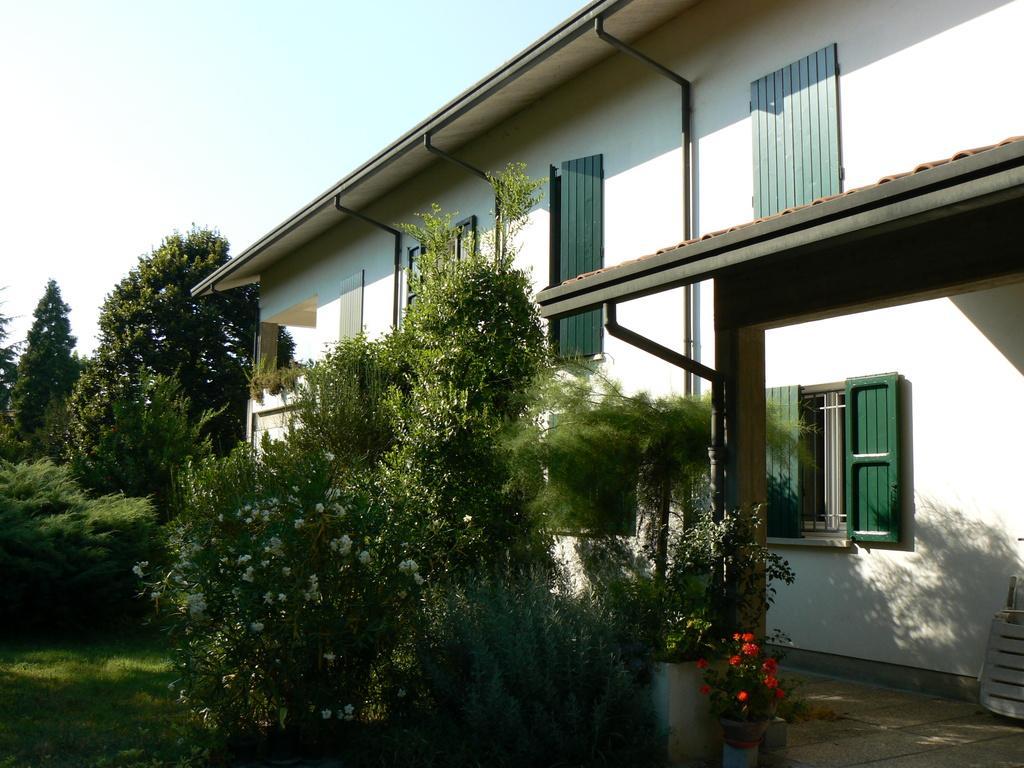What type of objects are present in the image that contain plants? There are flower pots in the image that contain small plants. What type of structure is visible in the image? There is a house in the image. What type of vegetation can be seen in the image besides the small plants in the flower pots? There are trees and grass in the image. What is visible in the background of the image? The sky is visible in the background of the image. How many rings does the expert wear while examining the plants in the image? There is no expert or rings present in the image; it features flower pots, small plants, a house, trees, grass, and the sky. 